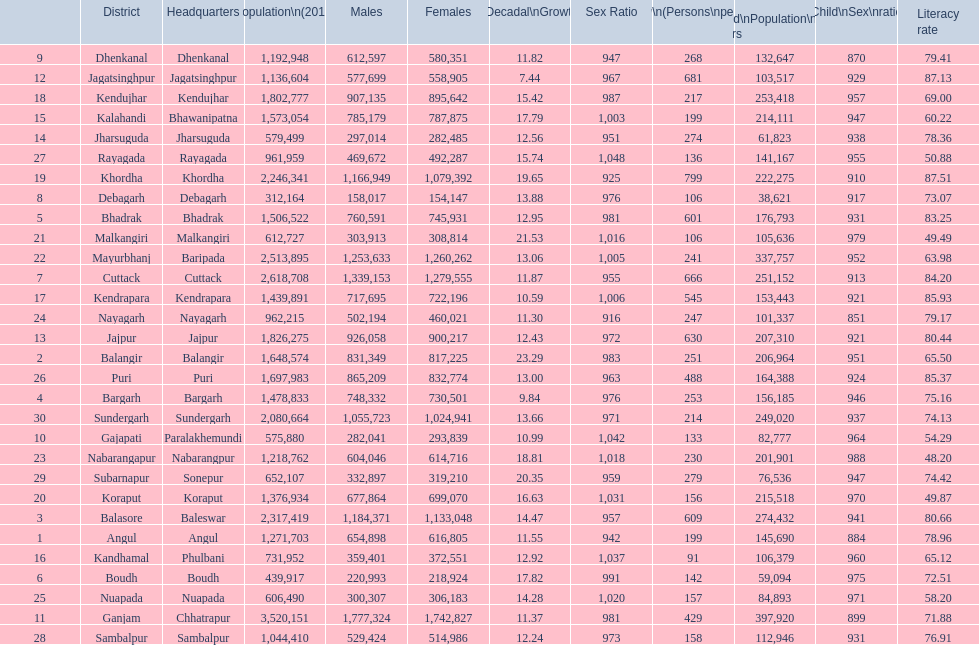Tell me a district that did not have a population over 600,000. Boudh. 